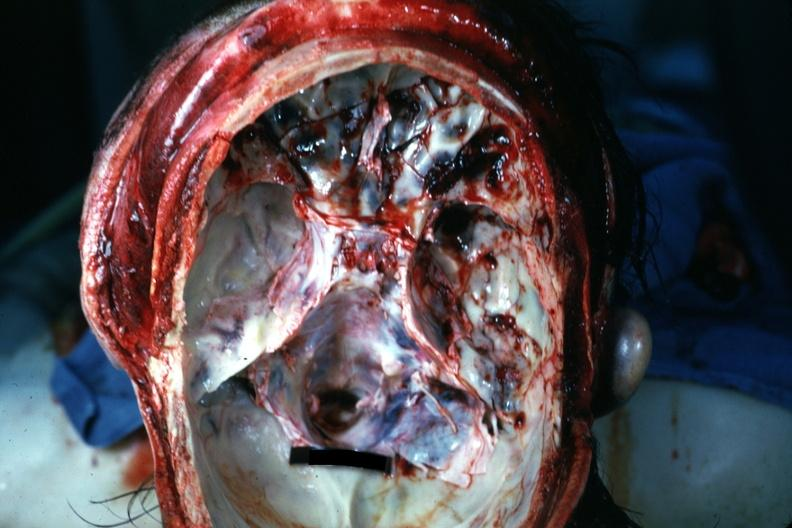s bone, calvarium present?
Answer the question using a single word or phrase. Yes 